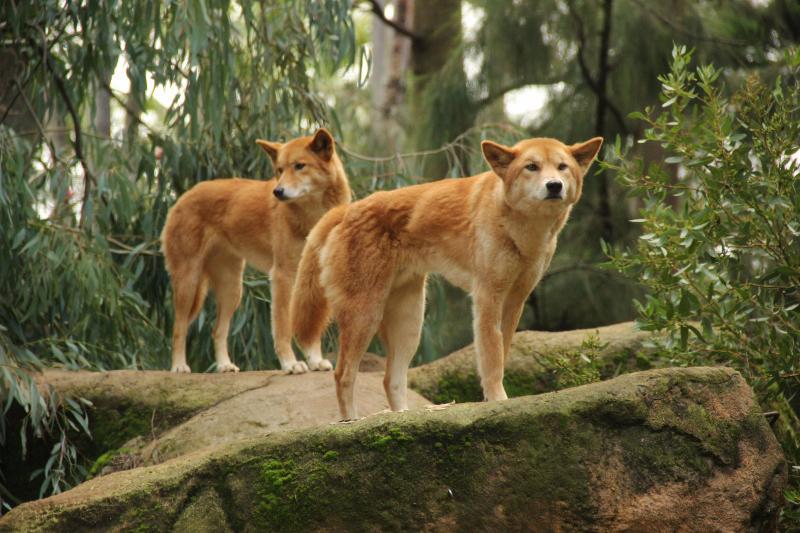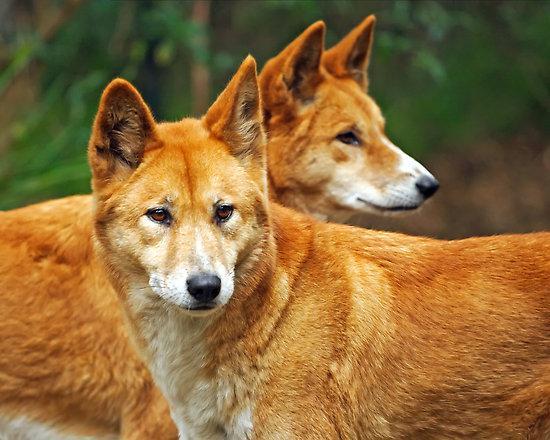The first image is the image on the left, the second image is the image on the right. For the images displayed, is the sentence "There are no less than four animals" factually correct? Answer yes or no. Yes. The first image is the image on the left, the second image is the image on the right. Examine the images to the left and right. Is the description "A total of three canine animals are shown." accurate? Answer yes or no. No. 